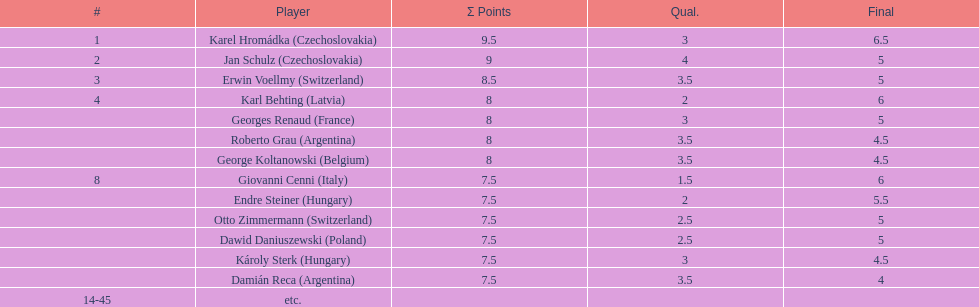How many players tied for 4th place? 4. 